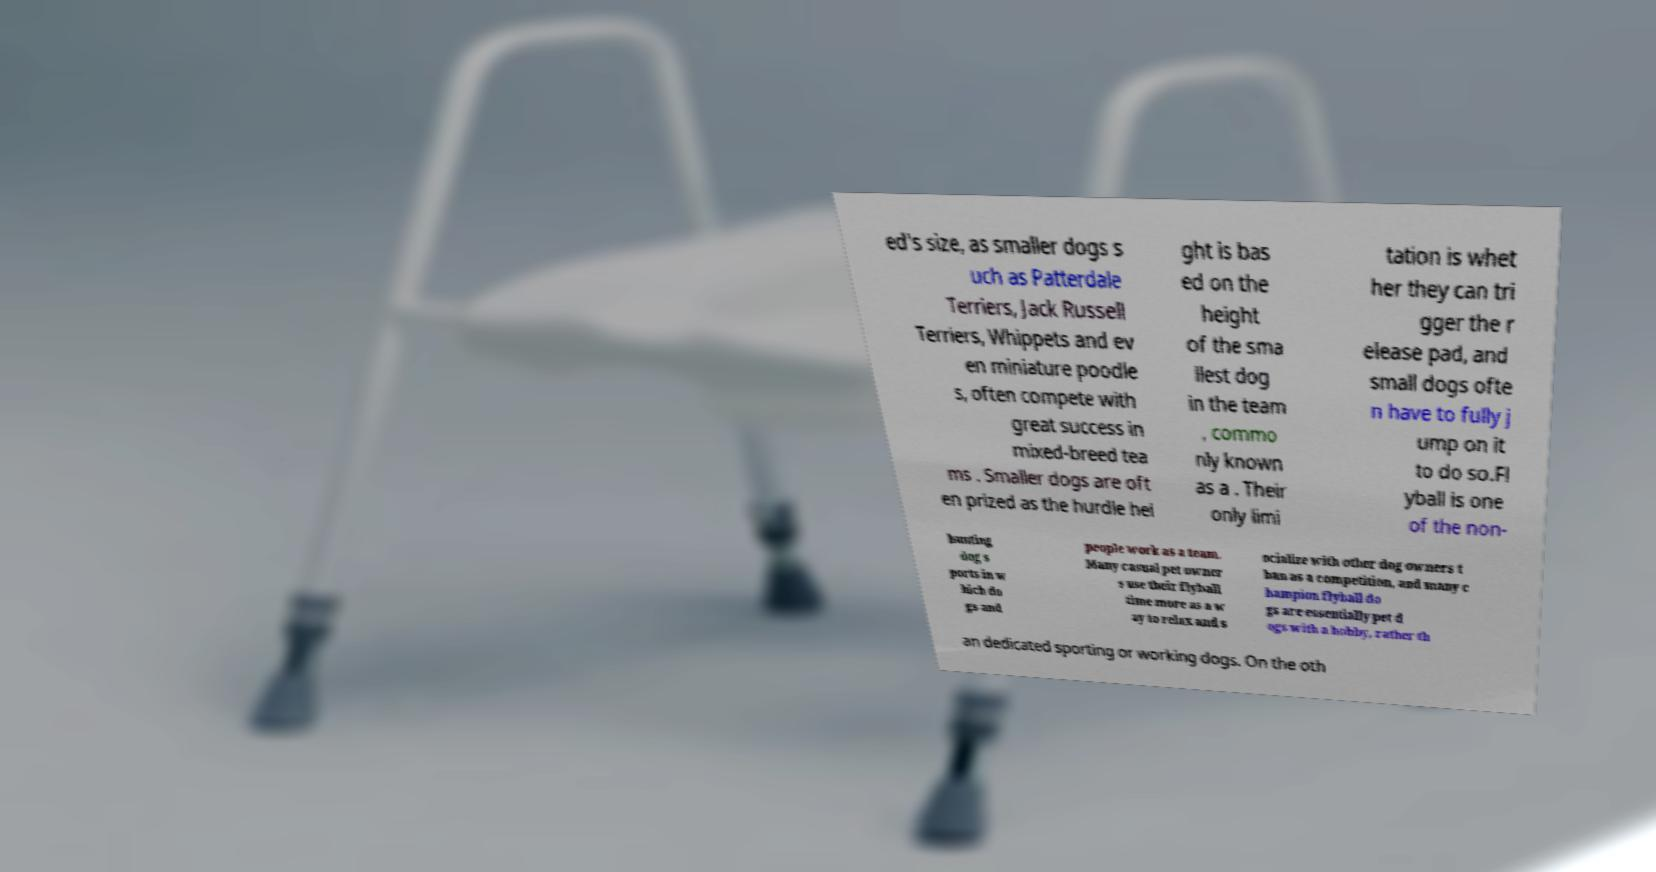For documentation purposes, I need the text within this image transcribed. Could you provide that? ed's size, as smaller dogs s uch as Patterdale Terriers, Jack Russell Terriers, Whippets and ev en miniature poodle s, often compete with great success in mixed-breed tea ms . Smaller dogs are oft en prized as the hurdle hei ght is bas ed on the height of the sma llest dog in the team , commo nly known as a . Their only limi tation is whet her they can tri gger the r elease pad, and small dogs ofte n have to fully j ump on it to do so.Fl yball is one of the non- hunting dog s ports in w hich do gs and people work as a team. Many casual pet owner s use their flyball time more as a w ay to relax and s ocialize with other dog owners t han as a competition, and many c hampion flyball do gs are essentially pet d ogs with a hobby, rather th an dedicated sporting or working dogs. On the oth 